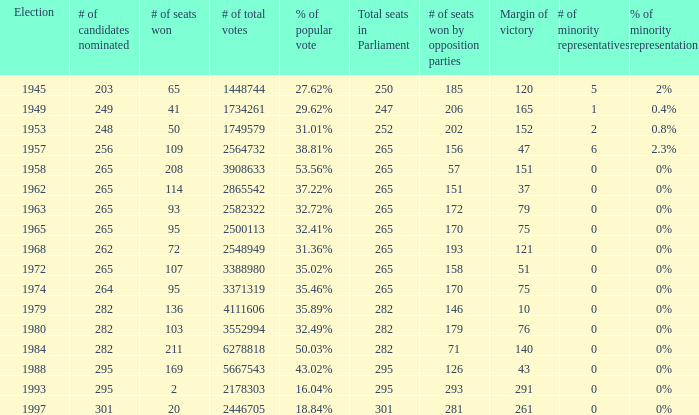What is the election year when the # of candidates nominated was 262? 1.0. 